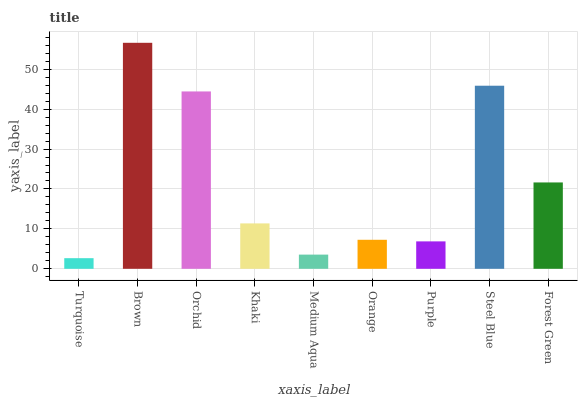Is Turquoise the minimum?
Answer yes or no. Yes. Is Brown the maximum?
Answer yes or no. Yes. Is Orchid the minimum?
Answer yes or no. No. Is Orchid the maximum?
Answer yes or no. No. Is Brown greater than Orchid?
Answer yes or no. Yes. Is Orchid less than Brown?
Answer yes or no. Yes. Is Orchid greater than Brown?
Answer yes or no. No. Is Brown less than Orchid?
Answer yes or no. No. Is Khaki the high median?
Answer yes or no. Yes. Is Khaki the low median?
Answer yes or no. Yes. Is Orchid the high median?
Answer yes or no. No. Is Brown the low median?
Answer yes or no. No. 